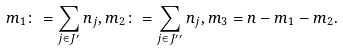<formula> <loc_0><loc_0><loc_500><loc_500>m _ { 1 } \colon = \sum _ { j \in J ^ { \prime } } n _ { j } , m _ { 2 } \colon = \sum _ { j \in J ^ { \prime \prime } } n _ { j } , m _ { 3 } = n - m _ { 1 } - m _ { 2 } .</formula> 